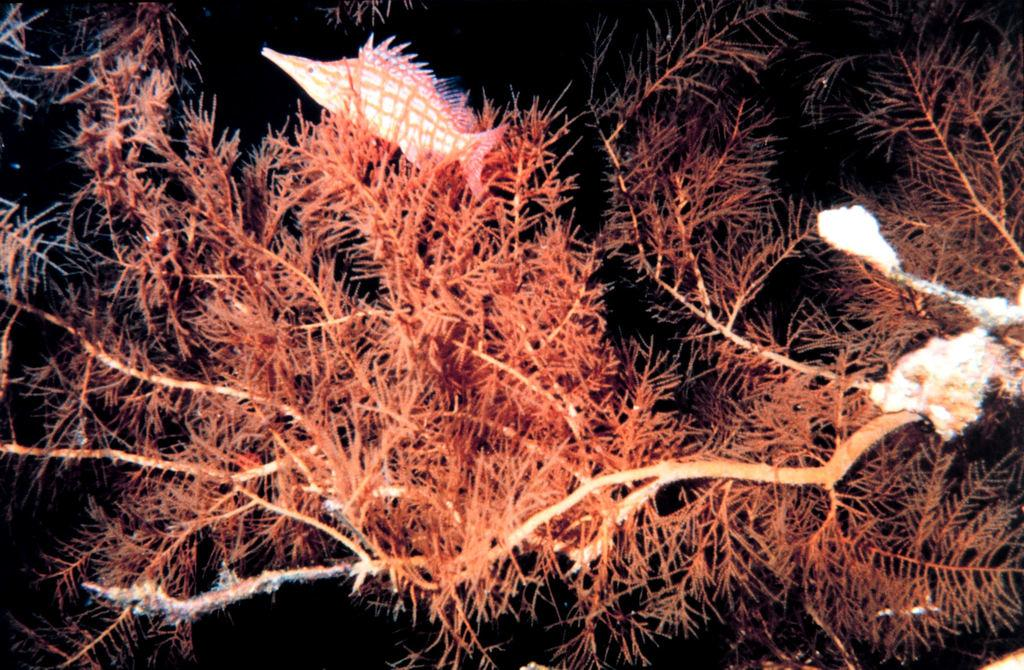What is located at the top of the image? There is a fish at the top of the image. What type of plants are at the bottom of the image? There are plants in red color at the bottom of the image. What type of bait is used to catch the fish in the image? There is no indication of bait or fishing in the image; it simply features a fish at the top and red plants at the bottom. Is the fish in the image contained within a glass container? There is no glass container present in the image. 